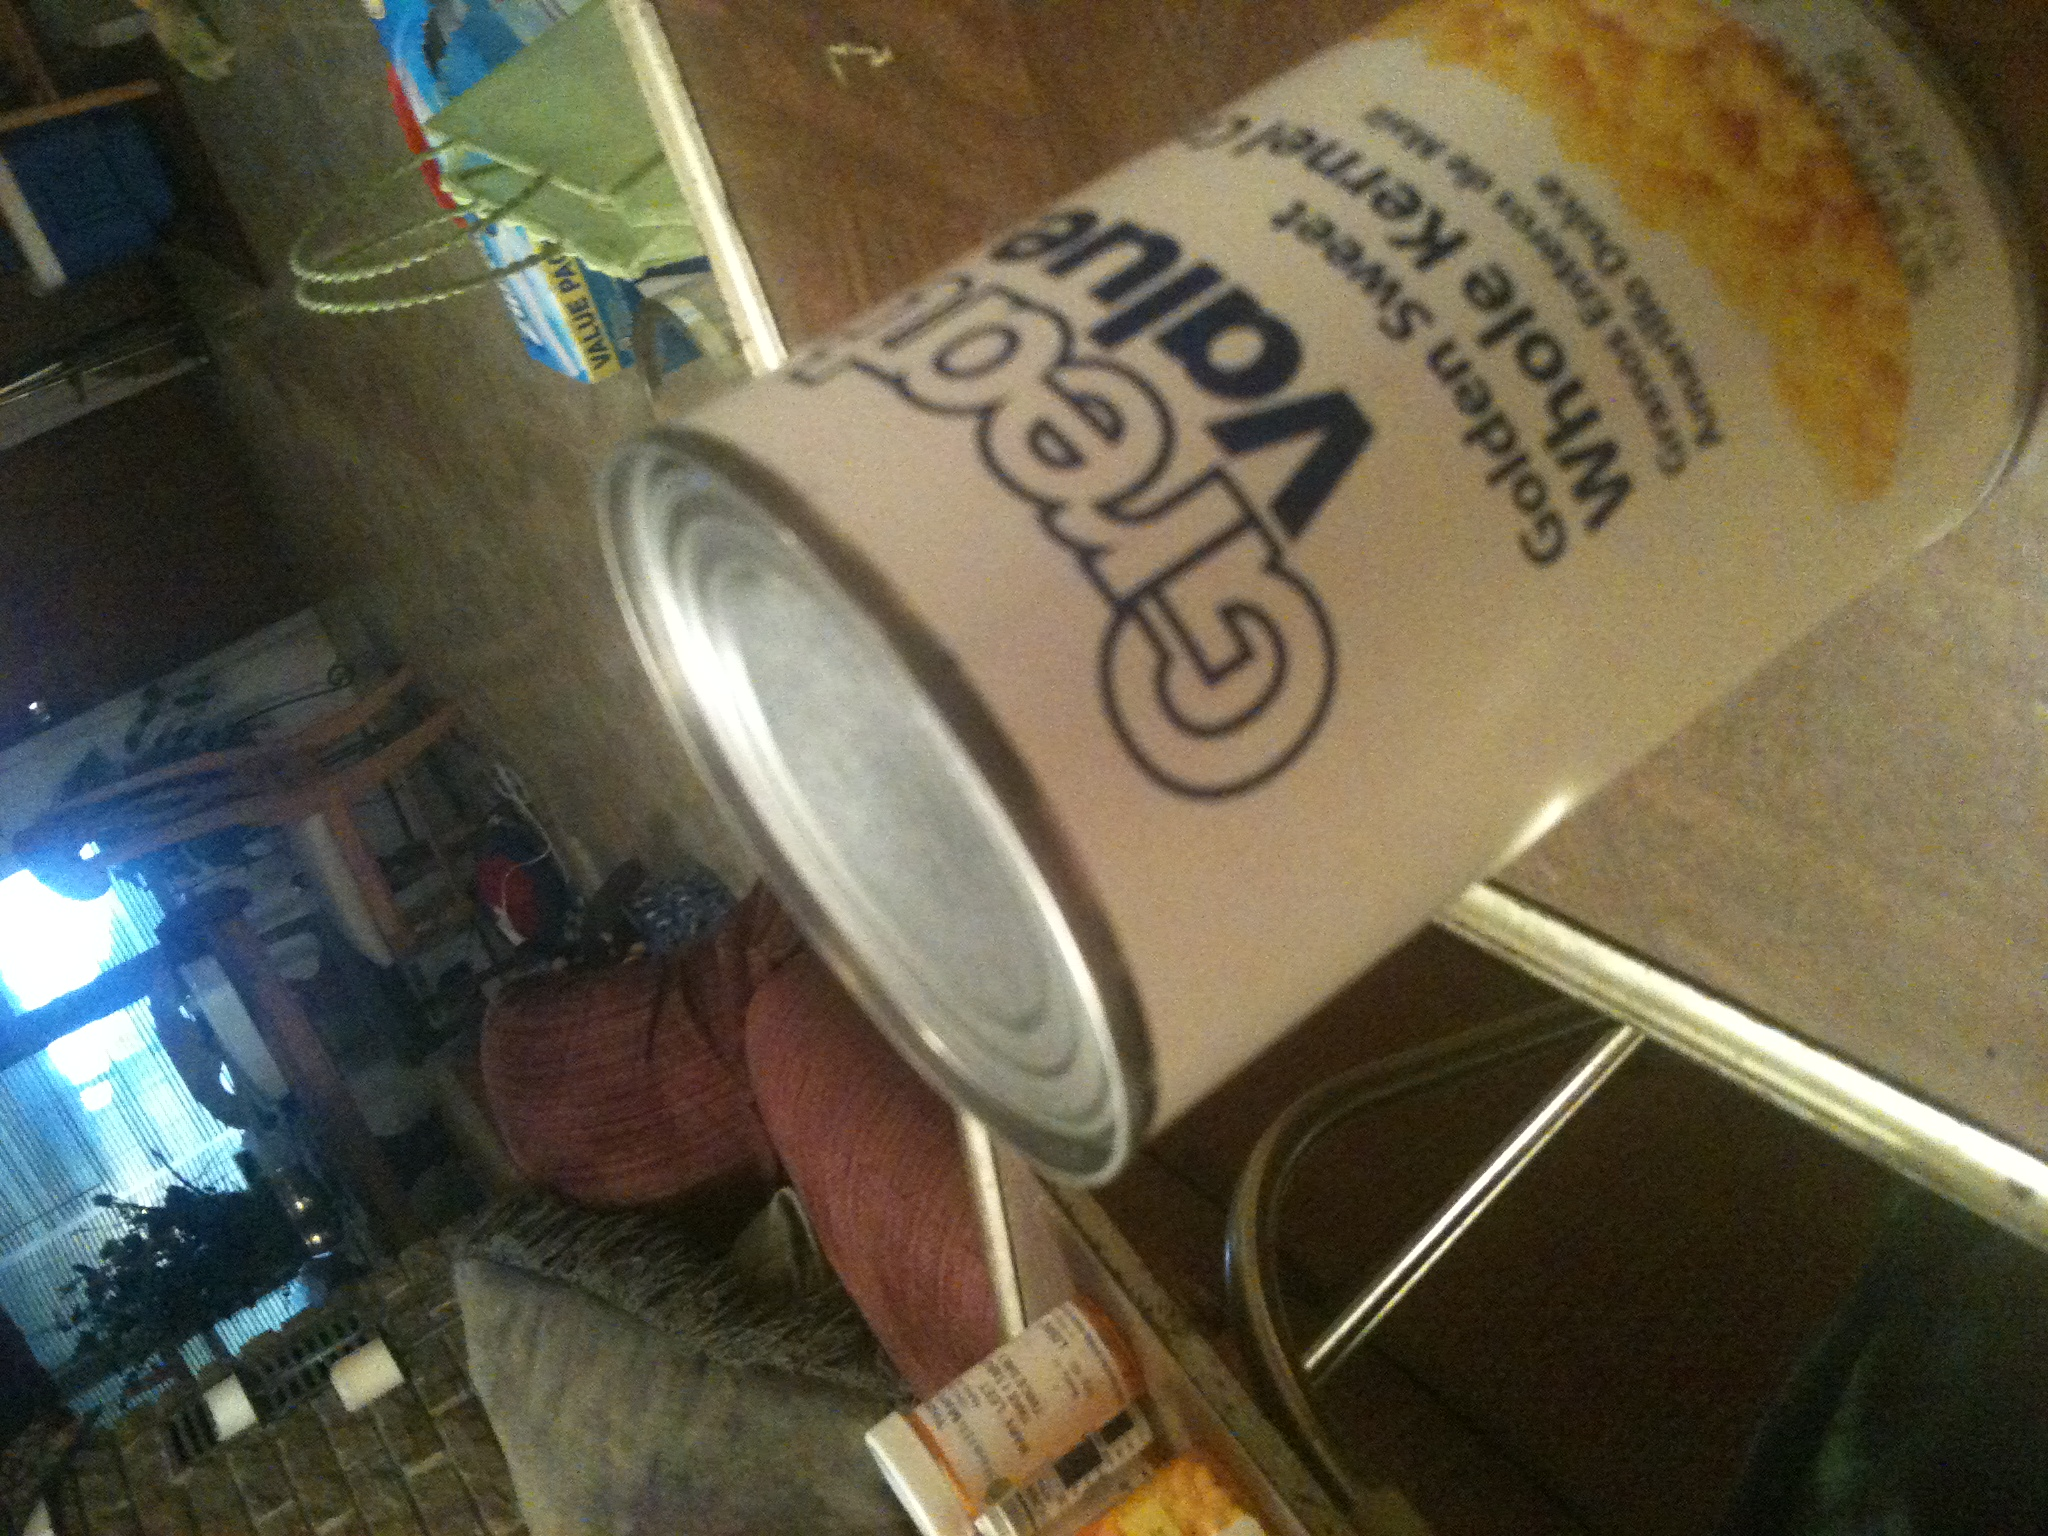Can you suggest a recipe that includes this type of corn? Absolutely! A quick and delicious recipe you can try is Corn and Black Bean Salad. Simply mix the corn from the can with black beans, chopped tomatoes, onions, and cilantro. Dress it with lime juice, olive oil, salt, and a pinch of cumin for a fresh, tasty dish. 